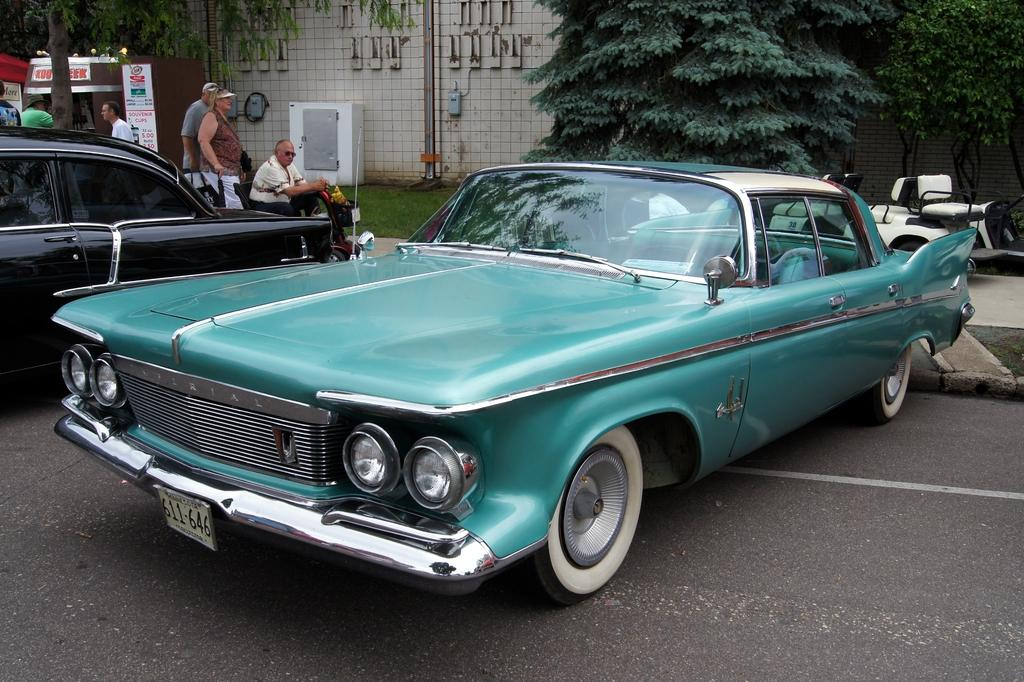What type of vehicles can be seen in the image? There are cars in the image. Can you describe the people in the image? There is a group of people in the image. What can be seen in the background of the image? There are trees, a building, and hoardings in the background of the image. What type of quilt is being used to cover the rail in the image? There is no quilt or rail present in the image. Can you describe the bed in the image? There is no bed present in the image. 